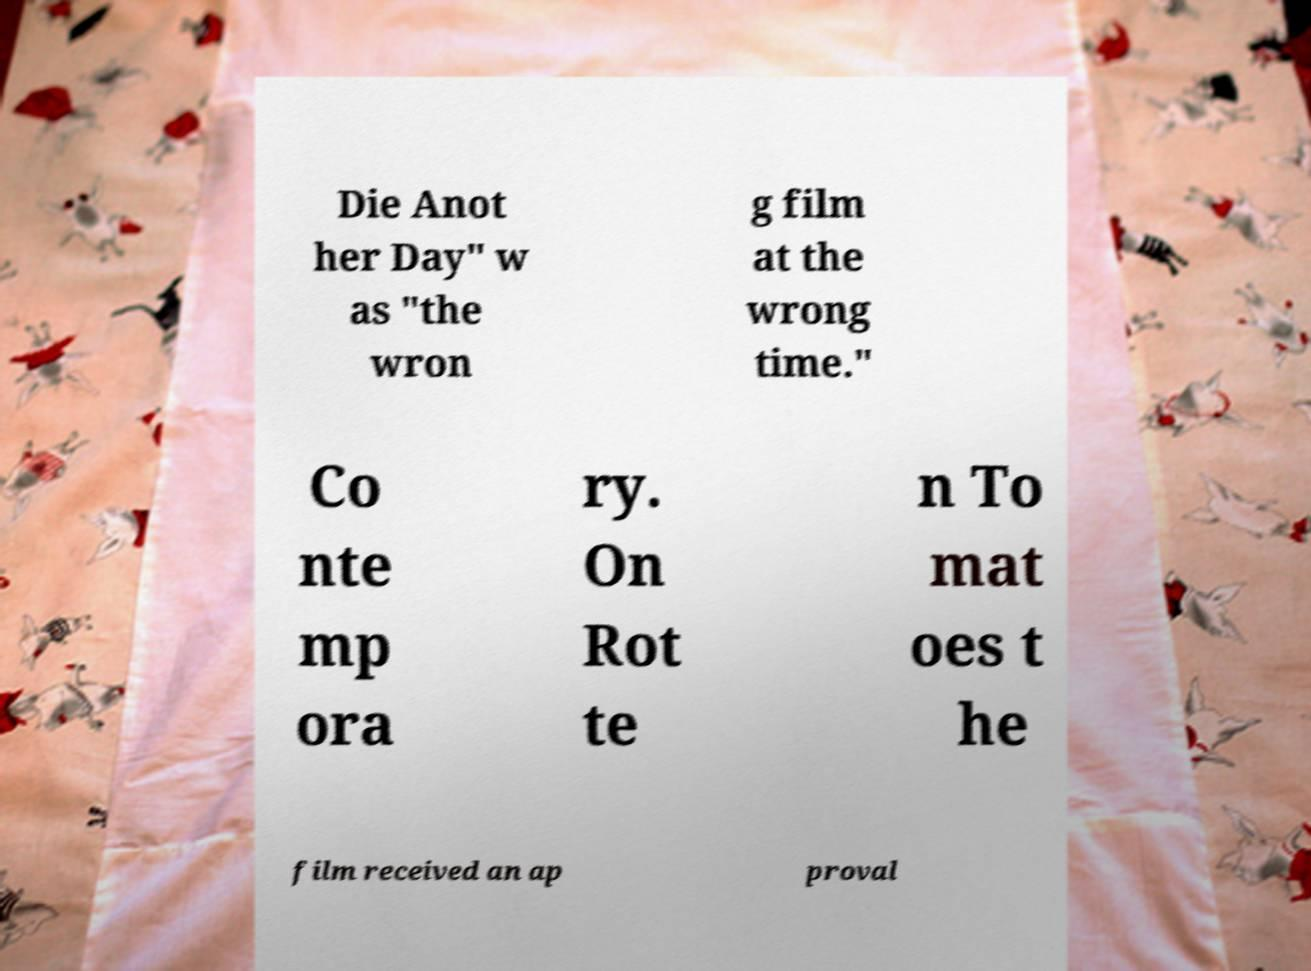Please identify and transcribe the text found in this image. Die Anot her Day" w as "the wron g film at the wrong time." Co nte mp ora ry. On Rot te n To mat oes t he film received an ap proval 